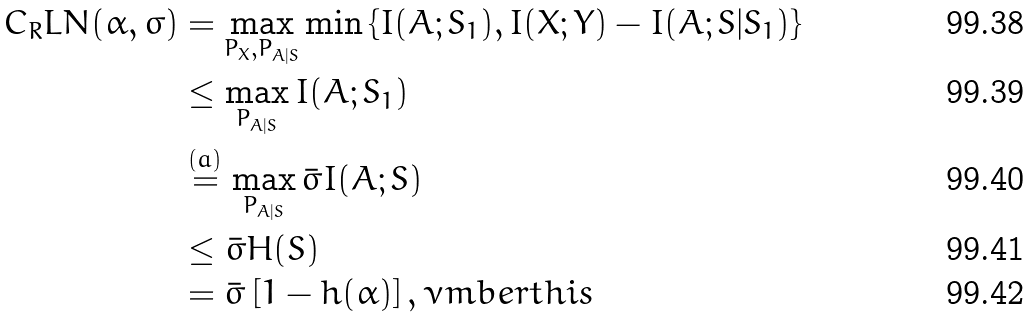Convert formula to latex. <formula><loc_0><loc_0><loc_500><loc_500>C _ { R } L N ( \alpha , \sigma ) & = \max _ { P _ { X } , P _ { A | S } } \min \left \{ I ( A ; S _ { 1 } ) , I ( X ; Y ) - I ( A ; S | S _ { 1 } ) \right \} \\ & \leq \max _ { P _ { A | S } } I ( A ; S _ { 1 } ) \\ & \stackrel { ( a ) } = \max _ { P _ { A | S } } \bar { \sigma } I ( A ; S ) \\ & \leq \bar { \sigma } H ( S ) \\ & = \bar { \sigma } \left [ 1 - h ( \alpha ) \right ] , \nu m b e r t h i s</formula> 